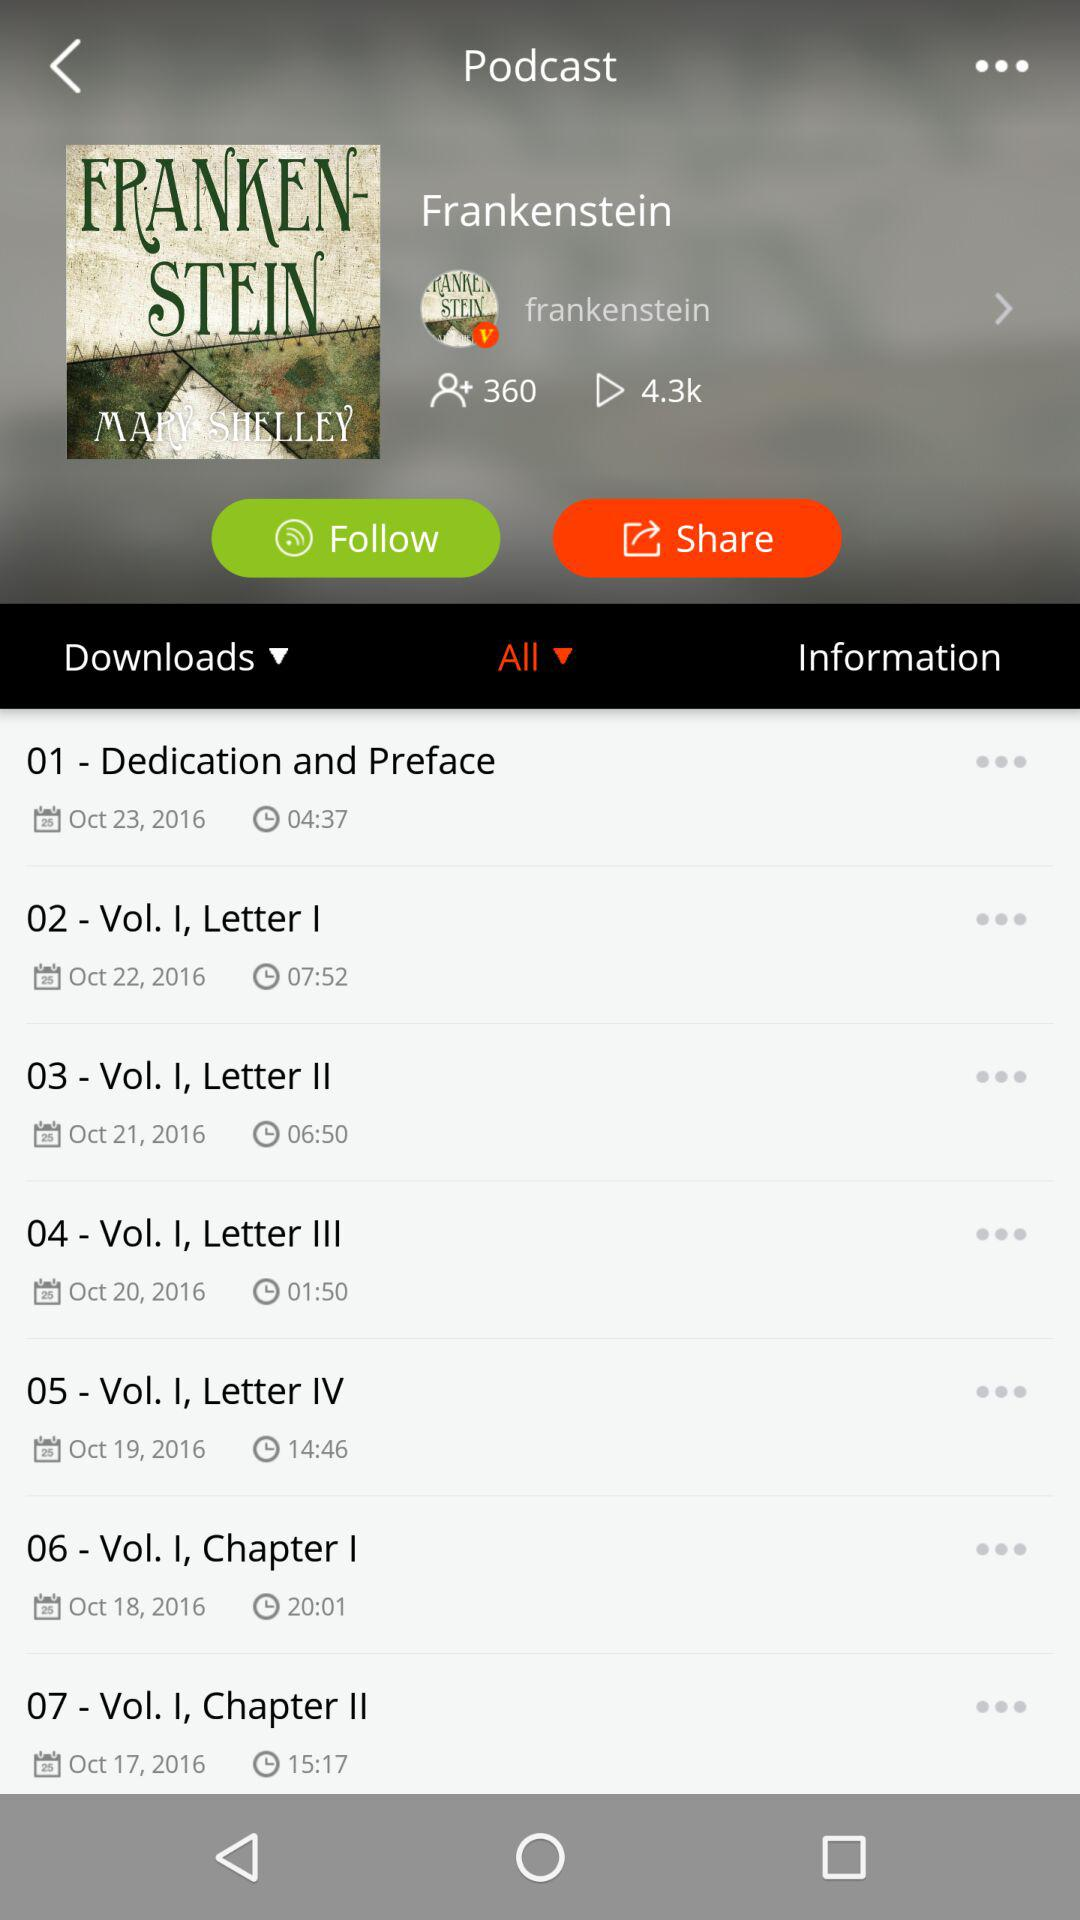What is the duration of the "Dedication and Preface"? The duration is 04:37. 